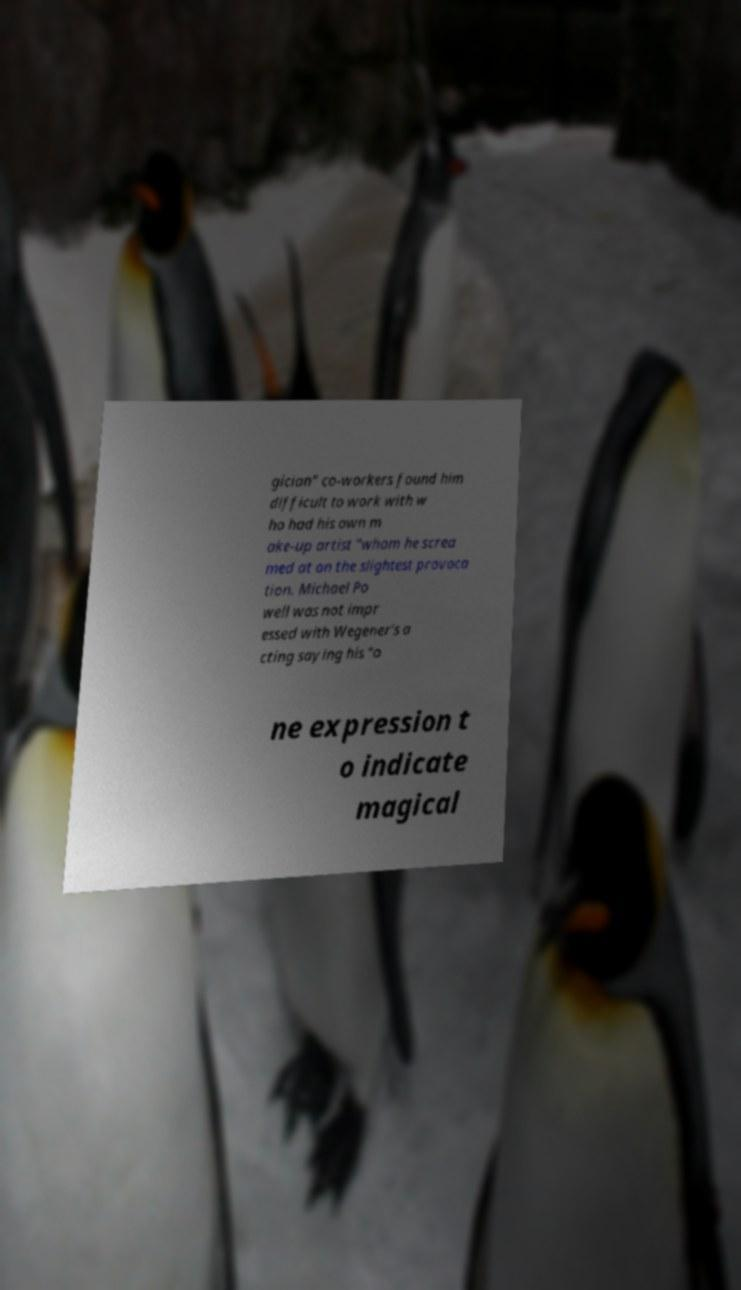Could you assist in decoding the text presented in this image and type it out clearly? gician" co-workers found him difficult to work with w ho had his own m ake-up artist "whom he screa med at on the slightest provoca tion. Michael Po well was not impr essed with Wegener's a cting saying his "o ne expression t o indicate magical 